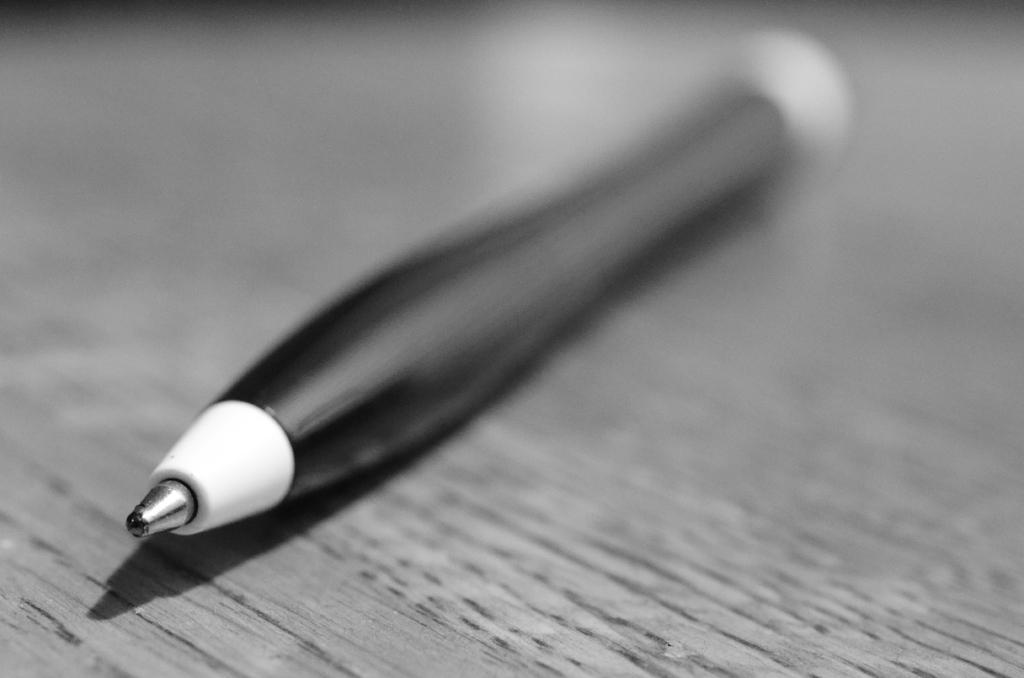Can you describe this image briefly? In this image I can see a pen on the wooden board. The image is in black and white. 